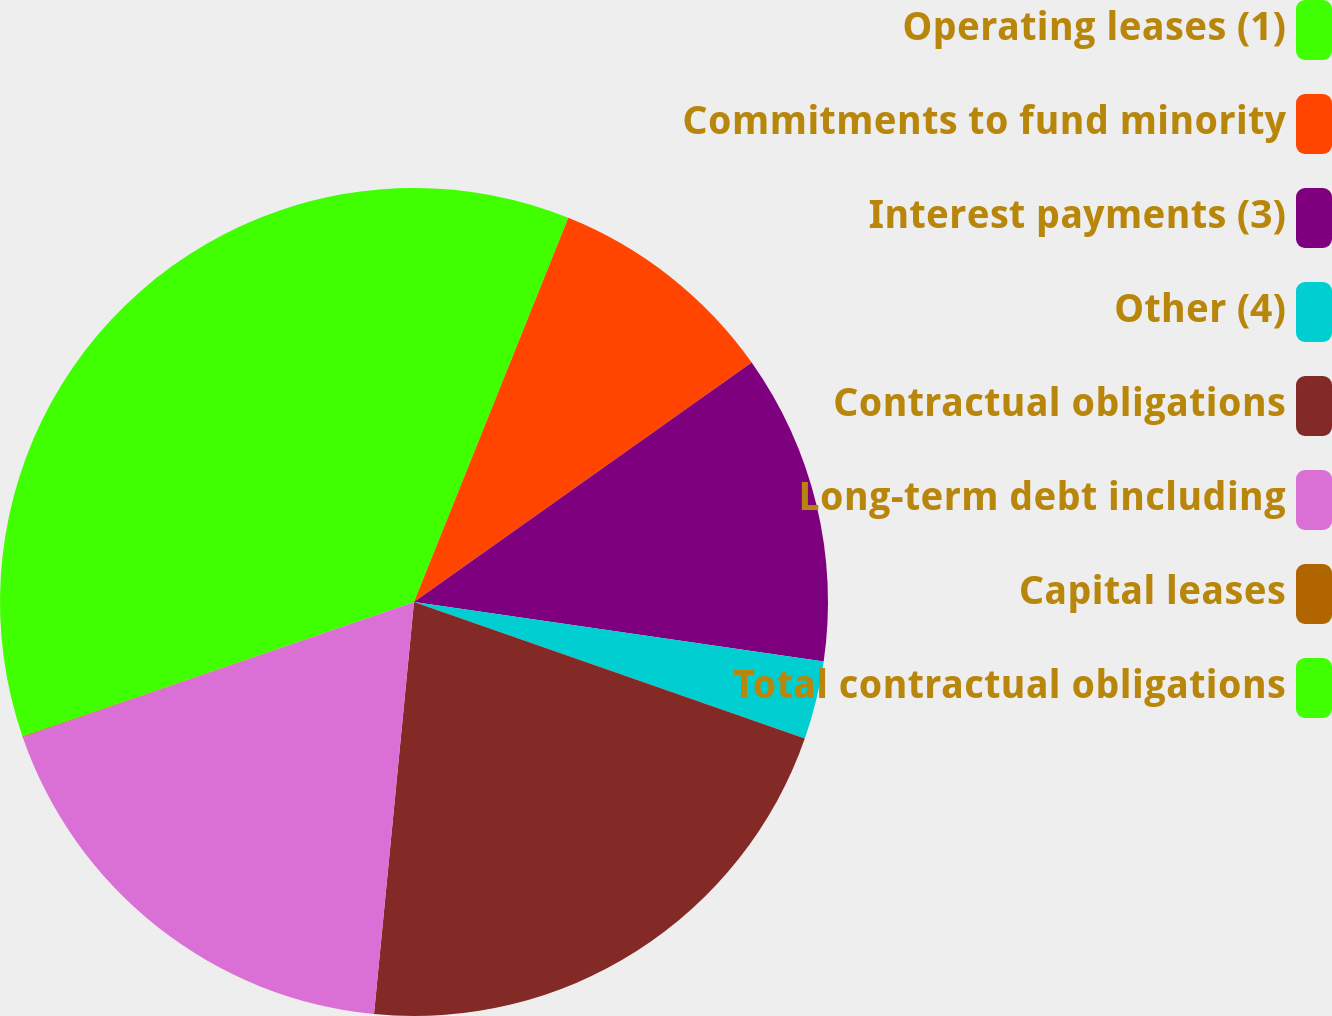Convert chart. <chart><loc_0><loc_0><loc_500><loc_500><pie_chart><fcel>Operating leases (1)<fcel>Commitments to fund minority<fcel>Interest payments (3)<fcel>Other (4)<fcel>Contractual obligations<fcel>Long-term debt including<fcel>Capital leases<fcel>Total contractual obligations<nl><fcel>6.08%<fcel>9.1%<fcel>12.12%<fcel>3.05%<fcel>21.19%<fcel>18.17%<fcel>0.03%<fcel>30.26%<nl></chart> 